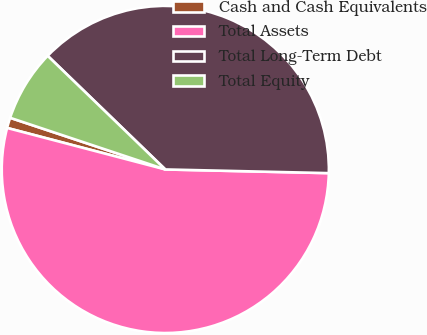Convert chart. <chart><loc_0><loc_0><loc_500><loc_500><pie_chart><fcel>Cash and Cash Equivalents<fcel>Total Assets<fcel>Total Long-Term Debt<fcel>Total Equity<nl><fcel>1.03%<fcel>53.72%<fcel>38.13%<fcel>7.11%<nl></chart> 